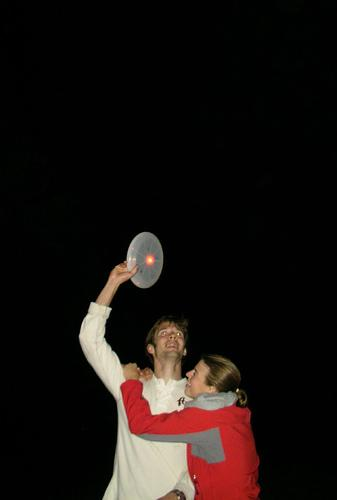Tell me about the appearance of the man and the woman in the image. The man is wearing a white shirt with a red logo, a wristwatch, and looking up. The woman has brown hair in a ponytail, wearing a red and grey hoodie, and clinging to the man. What colors are mentioned in relation to the subjects and the surrounding objects? Red, gray, white, orange, silver, and black. Briefly describe the visual Entailment task of the image. Determine if a given statement is entailed or contradicted by the information shown in the image of a couple hugging at night with a glowing frisbee. Choose one aspect of the image and propose a product advertisement for it. "Light up the night with our new, innovative glowing frisbee - perfect for creating unforgettable memories with your loved ones after the sun goes down!" In a multi-choice VQA task, write a question and provide the correct and incorrect choices. D) Red and Grey Hoodie (incorrect) State three characteristics of the frisbee in the image. The frisbee is white, has an orange light at its center, and is being held by the man. In referential expression grounding task, match the description of a subject with their location and appearance. Appearance: Wearing a wristwatch and looking up Describe the scene between the man and the woman in the image. A woman in a red and gray hoodie is hugging a man in a white shirt, who is holding a light-up frisbee and looking up into the night sky. What objects are being interacted with by the subjects in the image? The man is interacting with a light-up frisbee that glows orange in the center, and the woman is hugging the man. Write a short caption reflecting the essence of the image. A couple embraces under a black night sky as the man holds a glowing frisbee. 